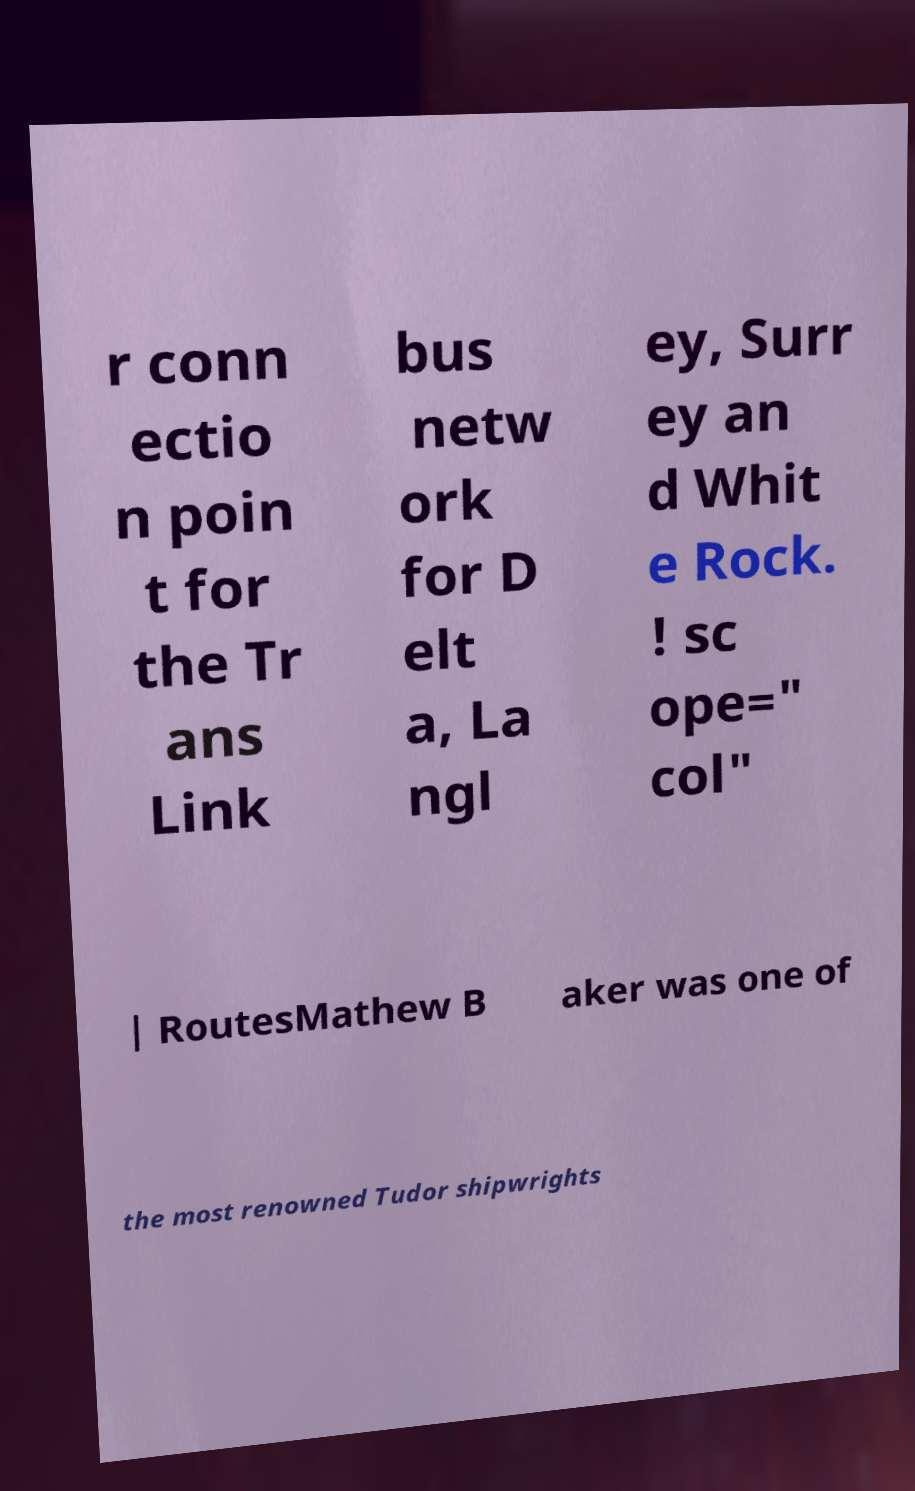There's text embedded in this image that I need extracted. Can you transcribe it verbatim? r conn ectio n poin t for the Tr ans Link bus netw ork for D elt a, La ngl ey, Surr ey an d Whit e Rock. ! sc ope=" col" | RoutesMathew B aker was one of the most renowned Tudor shipwrights 